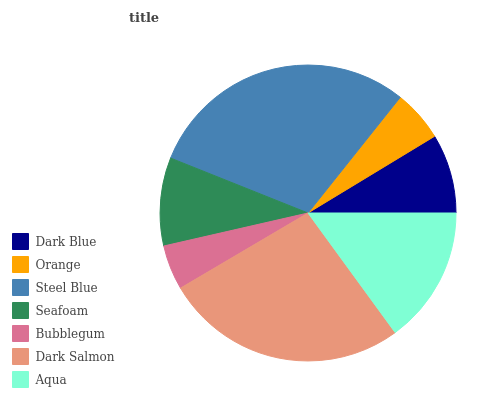Is Bubblegum the minimum?
Answer yes or no. Yes. Is Steel Blue the maximum?
Answer yes or no. Yes. Is Orange the minimum?
Answer yes or no. No. Is Orange the maximum?
Answer yes or no. No. Is Dark Blue greater than Orange?
Answer yes or no. Yes. Is Orange less than Dark Blue?
Answer yes or no. Yes. Is Orange greater than Dark Blue?
Answer yes or no. No. Is Dark Blue less than Orange?
Answer yes or no. No. Is Seafoam the high median?
Answer yes or no. Yes. Is Seafoam the low median?
Answer yes or no. Yes. Is Steel Blue the high median?
Answer yes or no. No. Is Orange the low median?
Answer yes or no. No. 